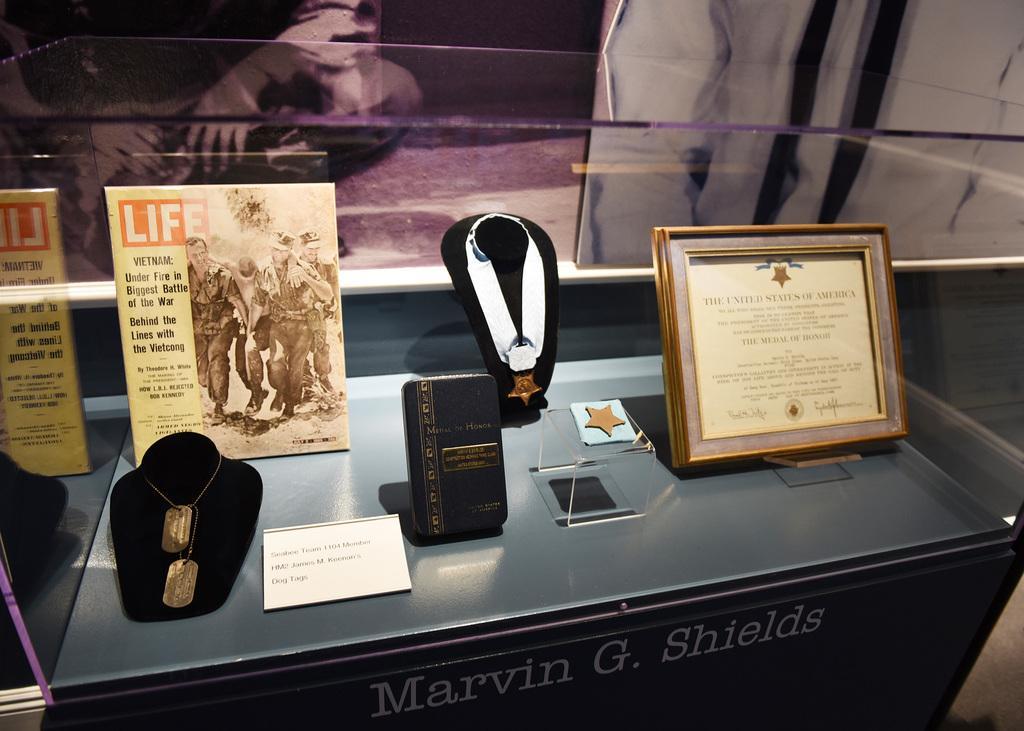How would you summarize this image in a sentence or two? In this image there is a showcase in that there are medals and certificates. 